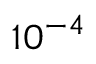<formula> <loc_0><loc_0><loc_500><loc_500>1 0 ^ { - 4 }</formula> 